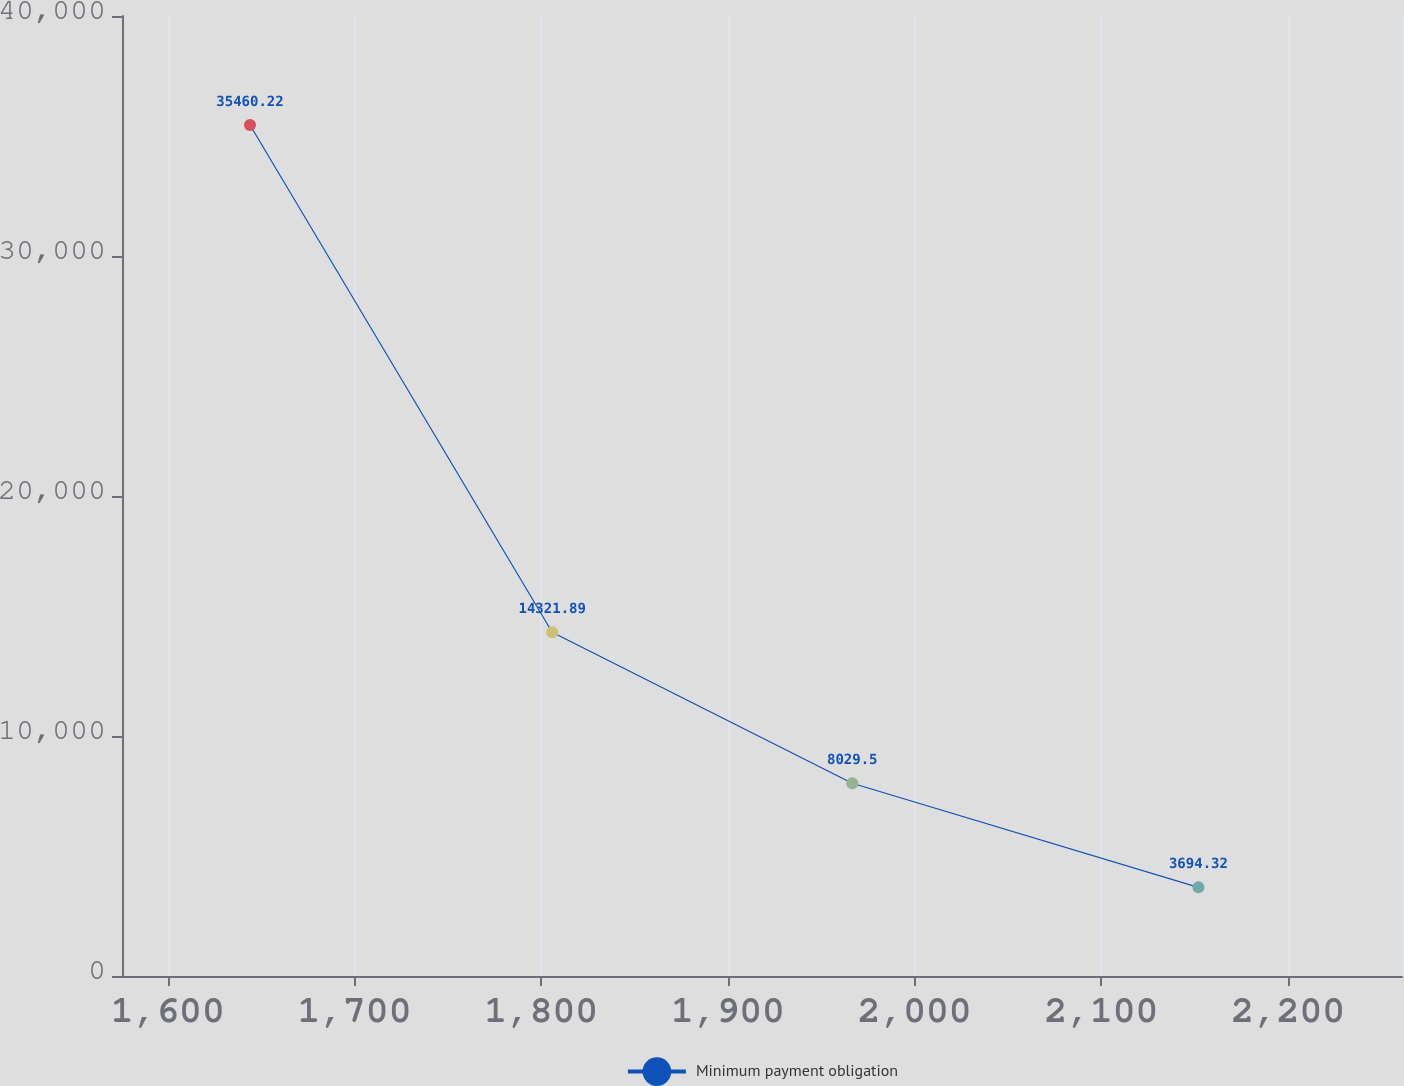Convert chart to OTSL. <chart><loc_0><loc_0><loc_500><loc_500><line_chart><ecel><fcel>Minimum payment obligation<nl><fcel>1644.08<fcel>35460.2<nl><fcel>1805.91<fcel>14321.9<nl><fcel>1966.58<fcel>8029.5<nl><fcel>2151.96<fcel>3694.32<nl><fcel>2329.52<fcel>164.78<nl></chart> 